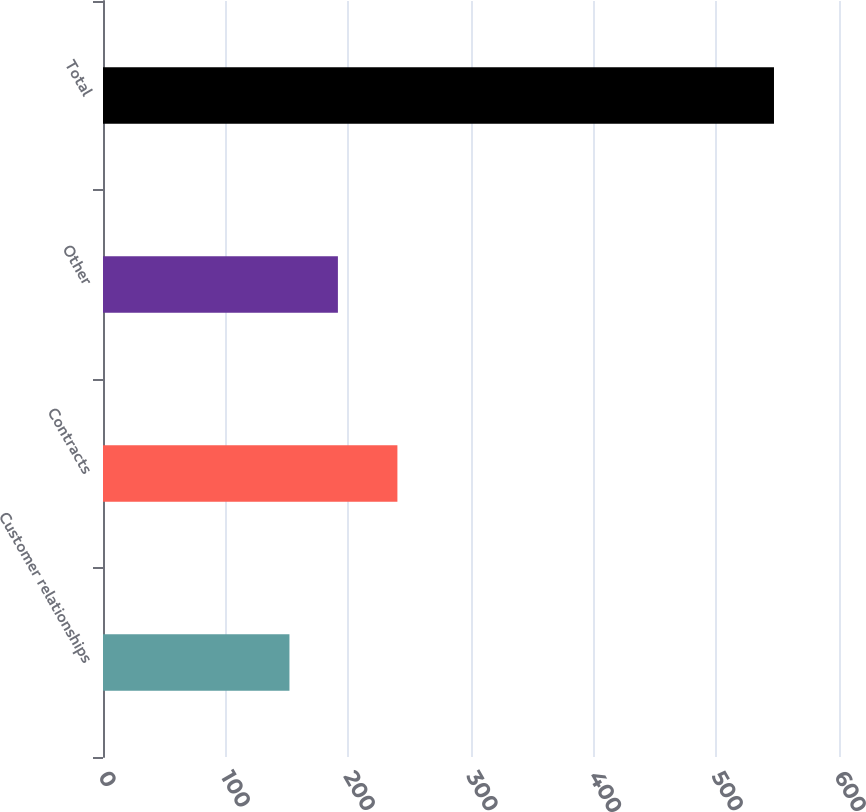<chart> <loc_0><loc_0><loc_500><loc_500><bar_chart><fcel>Customer relationships<fcel>Contracts<fcel>Other<fcel>Total<nl><fcel>152<fcel>240<fcel>191.5<fcel>547<nl></chart> 